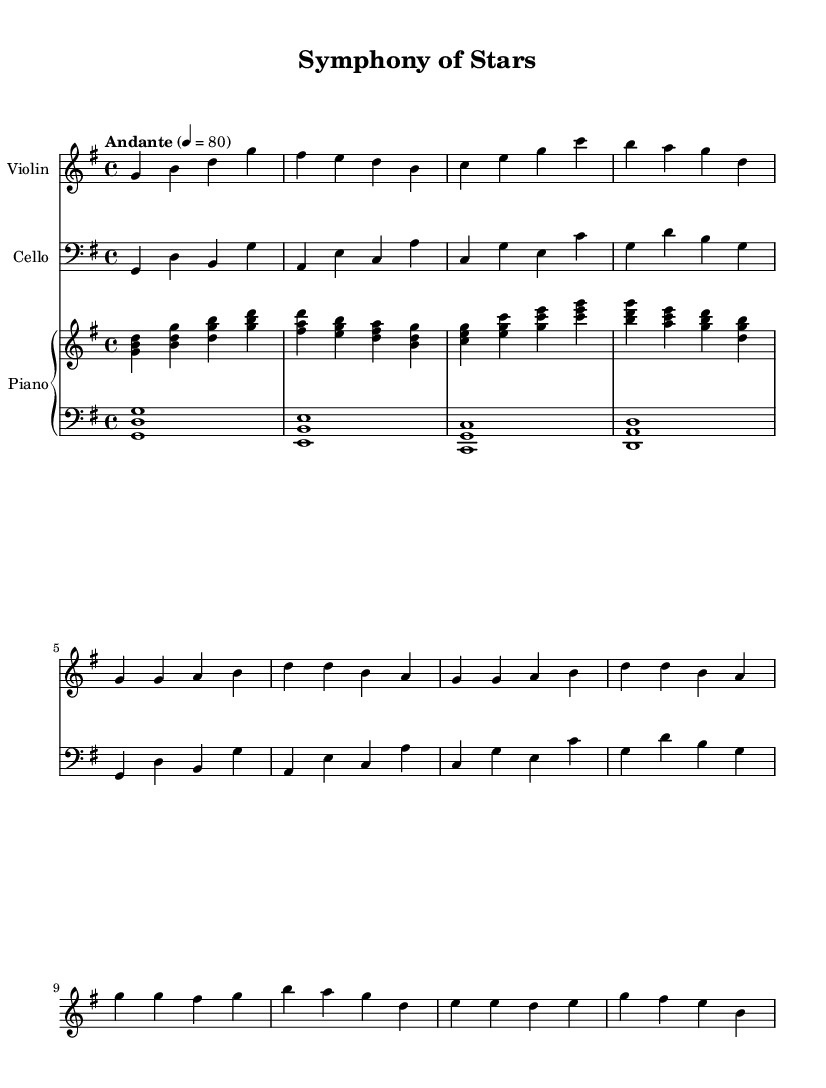What is the key signature of this music? The key signature is G major, which has one sharp. This can be determined by looking for the sharp symbol in the key signature section at the beginning of the staff.
Answer: G major What is the time signature of this music? The time signature is 4/4, indicated right after the key signature. This means there are four beats per measure and the quarter note receives one beat.
Answer: 4/4 What is the tempo marking of the music? The tempo marking is "Andante," which means a moderate pace. The tempo is indicated at the start of the score, typically specifying the speed of the piece.
Answer: Andante How many measures are there in the piece? There are 8 measures visible in the excerpt, numbered from the beginning to the end of the provided music notation. This can be determined by counting the vertical lines separating each group of notes.
Answer: 8 What is the range of the instruments used in this piece? The range encompasses from G in the cello part to the higher G in the violin part. The lowest note in the cello part is G, and the highest in the violin part is G', showing the span of notes used across instruments.
Answer: G to G prime Which instrument has the highest pitch notes in this piece? The violin has the highest pitch notes as seen in its part, which reaches G'. This is evident by comparing note placements on the staff; higher notes indicate higher pitches.
Answer: Violin Do any of the instruments play the same notes at the same time? Yes, there are moments where both the piano and violin parts play the note G simultaneously, which is evident in measure 1 where the note G appears in both parts.
Answer: Yes 